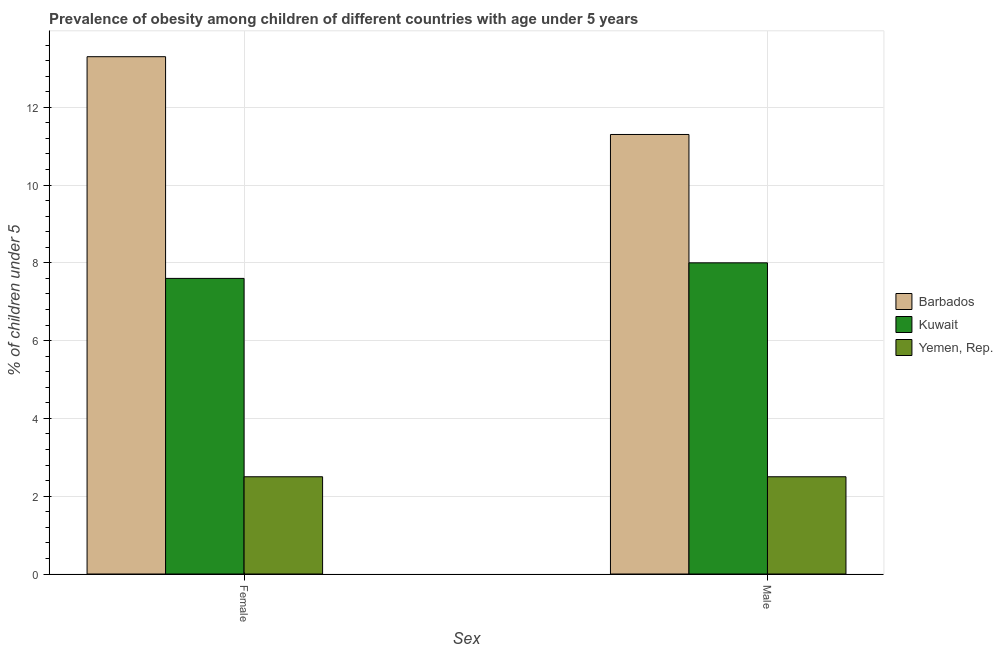How many different coloured bars are there?
Ensure brevity in your answer.  3. Are the number of bars per tick equal to the number of legend labels?
Make the answer very short. Yes. Are the number of bars on each tick of the X-axis equal?
Your answer should be very brief. Yes. What is the label of the 1st group of bars from the left?
Give a very brief answer. Female. Across all countries, what is the maximum percentage of obese female children?
Your answer should be compact. 13.3. In which country was the percentage of obese female children maximum?
Keep it short and to the point. Barbados. In which country was the percentage of obese female children minimum?
Give a very brief answer. Yemen, Rep. What is the total percentage of obese male children in the graph?
Your answer should be compact. 21.8. What is the difference between the percentage of obese female children in Barbados and that in Kuwait?
Keep it short and to the point. 5.7. What is the difference between the percentage of obese female children in Kuwait and the percentage of obese male children in Yemen, Rep.?
Keep it short and to the point. 5.1. What is the average percentage of obese male children per country?
Offer a terse response. 7.27. What is the difference between the percentage of obese male children and percentage of obese female children in Kuwait?
Provide a succinct answer. 0.4. In how many countries, is the percentage of obese female children greater than 2.8 %?
Provide a short and direct response. 2. What is the ratio of the percentage of obese female children in Kuwait to that in Barbados?
Your response must be concise. 0.57. Is the percentage of obese female children in Yemen, Rep. less than that in Barbados?
Ensure brevity in your answer.  Yes. In how many countries, is the percentage of obese female children greater than the average percentage of obese female children taken over all countries?
Provide a short and direct response. 1. What does the 3rd bar from the left in Male represents?
Provide a short and direct response. Yemen, Rep. What does the 3rd bar from the right in Female represents?
Your answer should be compact. Barbados. Are the values on the major ticks of Y-axis written in scientific E-notation?
Your answer should be compact. No. Where does the legend appear in the graph?
Ensure brevity in your answer.  Center right. How many legend labels are there?
Offer a very short reply. 3. How are the legend labels stacked?
Your answer should be compact. Vertical. What is the title of the graph?
Make the answer very short. Prevalence of obesity among children of different countries with age under 5 years. Does "Singapore" appear as one of the legend labels in the graph?
Offer a terse response. No. What is the label or title of the X-axis?
Your answer should be very brief. Sex. What is the label or title of the Y-axis?
Your response must be concise.  % of children under 5. What is the  % of children under 5 in Barbados in Female?
Give a very brief answer. 13.3. What is the  % of children under 5 in Kuwait in Female?
Ensure brevity in your answer.  7.6. What is the  % of children under 5 in Yemen, Rep. in Female?
Your answer should be compact. 2.5. What is the  % of children under 5 of Yemen, Rep. in Male?
Your answer should be compact. 2.5. Across all Sex, what is the maximum  % of children under 5 in Kuwait?
Make the answer very short. 8. Across all Sex, what is the minimum  % of children under 5 in Kuwait?
Give a very brief answer. 7.6. What is the total  % of children under 5 in Barbados in the graph?
Make the answer very short. 24.6. What is the difference between the  % of children under 5 in Barbados in Female and that in Male?
Your answer should be very brief. 2. What is the difference between the  % of children under 5 of Kuwait in Female and that in Male?
Offer a very short reply. -0.4. What is the average  % of children under 5 of Barbados per Sex?
Give a very brief answer. 12.3. What is the average  % of children under 5 of Kuwait per Sex?
Your answer should be compact. 7.8. What is the average  % of children under 5 of Yemen, Rep. per Sex?
Your answer should be compact. 2.5. What is the difference between the  % of children under 5 in Barbados and  % of children under 5 in Kuwait in Male?
Give a very brief answer. 3.3. What is the difference between the  % of children under 5 in Kuwait and  % of children under 5 in Yemen, Rep. in Male?
Provide a succinct answer. 5.5. What is the ratio of the  % of children under 5 in Barbados in Female to that in Male?
Give a very brief answer. 1.18. What is the ratio of the  % of children under 5 of Yemen, Rep. in Female to that in Male?
Your response must be concise. 1. What is the difference between the highest and the second highest  % of children under 5 in Yemen, Rep.?
Provide a succinct answer. 0. What is the difference between the highest and the lowest  % of children under 5 in Kuwait?
Keep it short and to the point. 0.4. 